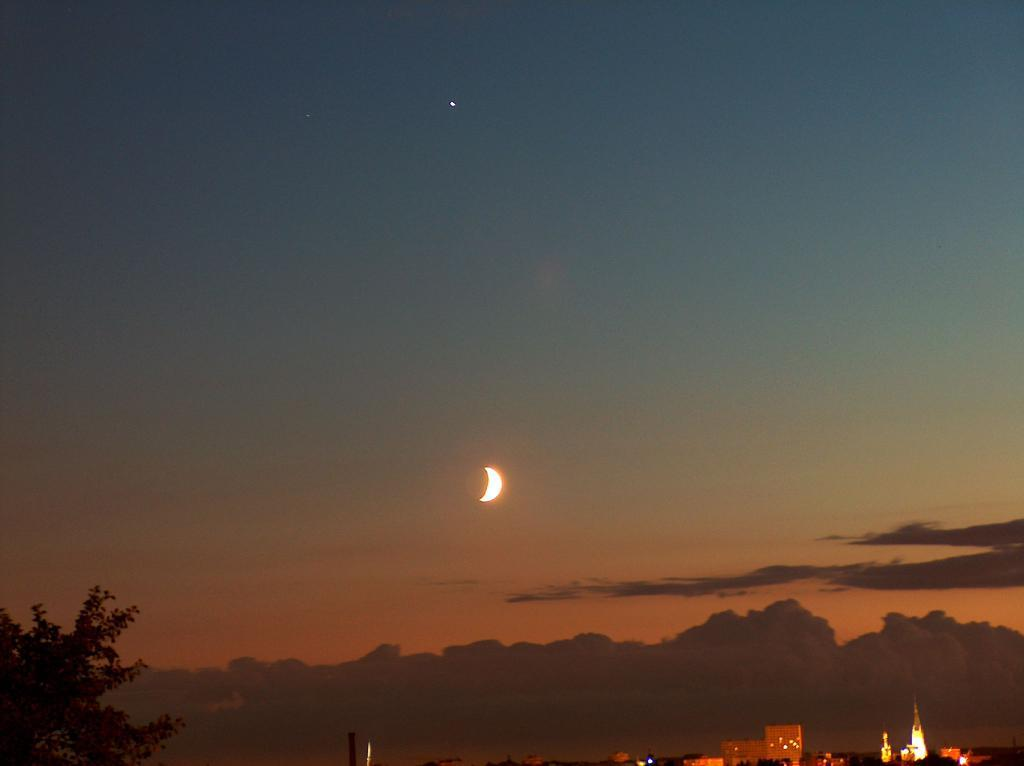What type of structures can be seen in the image? There are buildings in the image. What else is present in the image besides the buildings? There are lights, branches, and the sky visible in the image. What can be seen in the sky in the image? The sky in the image has clouds and the moon visible. How much money does the daughter have in her hand in the image? There is no daughter present in the image, and therefore no money or hand to consider. 